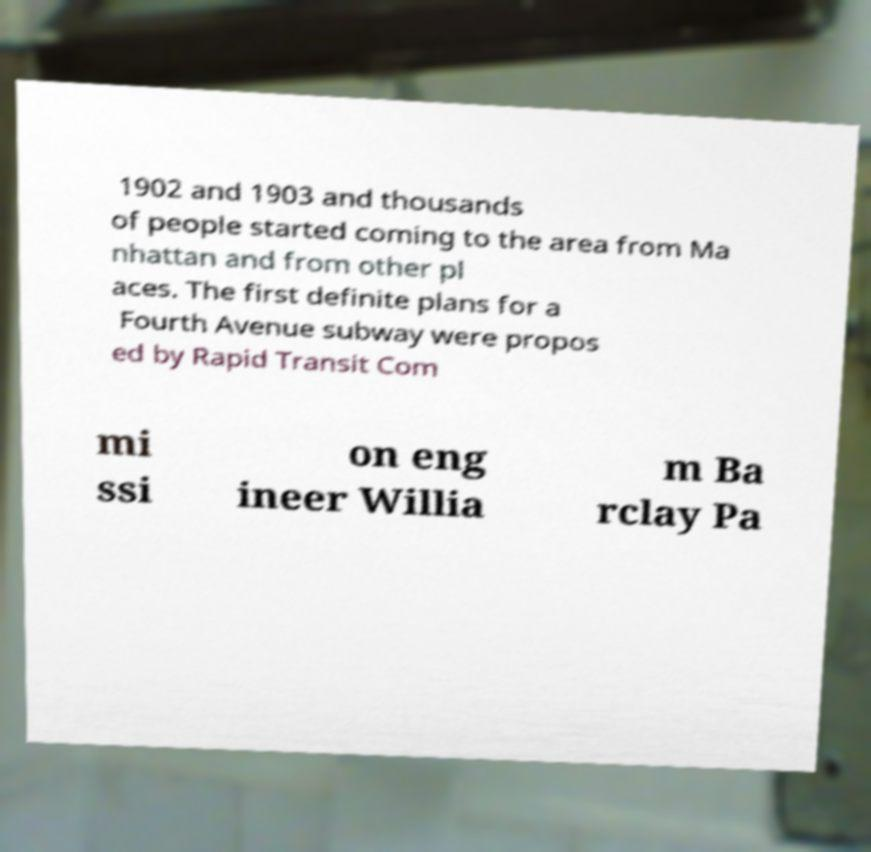For documentation purposes, I need the text within this image transcribed. Could you provide that? 1902 and 1903 and thousands of people started coming to the area from Ma nhattan and from other pl aces. The first definite plans for a Fourth Avenue subway were propos ed by Rapid Transit Com mi ssi on eng ineer Willia m Ba rclay Pa 